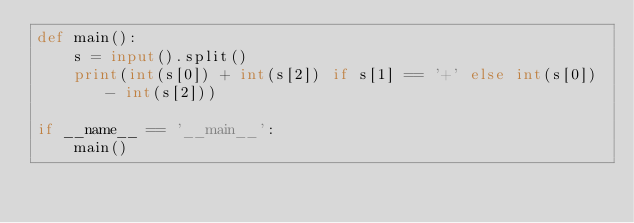Convert code to text. <code><loc_0><loc_0><loc_500><loc_500><_Python_>def main():
    s = input().split()
    print(int(s[0]) + int(s[2]) if s[1] == '+' else int(s[0]) - int(s[2]))

if __name__ == '__main__':
    main()
</code> 